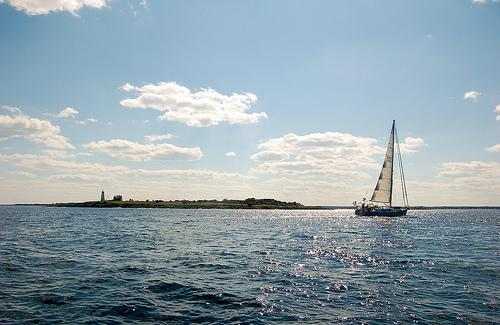Describe the quality of the light and its effect in the image. The light is bright and creates a reflection of sunlight in the calm blue water. In the context of object detection, how many separate object descriptions are provided in the image? There are 40 separate object descriptions in the image. What does the boat in the image look like and what is it doing? The boat is blue and white, sailing calmly on the water near land and a small island. Based on the visual elements, describe the general sentiment of the image. The image has a peaceful and serene sentiment, with calm water, clear sky, and gentle sailing. Analyze the interaction between the main objects in the image. The sailboat is sailing on the water near the land and small island, with the lighthouse visible in the distance. Identify the type of boat in the image and mention any visible parts of it. It's a sailboat with a white sail and a blue body, sailing on calm water. Who are the mentioned photographers or owners of this photo? Jackson Mingus and Zander Zeke are associated with this photo. Provide a brief description of the location where this photo was taken, including any landmarks. The photo was taken on the east coast in Boston, featuring a lighthouse, a small island, and an American flag. Can you count the number of objects described as "white clouds in blue sky"?  There are 9 instances of "white clouds in blue sky" descriptions. Describe the weather and environment in the image. The weather is clear with white, fluffy clouds in the blue sky, and the environment has calm, reflective blue water. Are there dark stormy clouds in the sky? All the captions about the clouds describe them as white, fluffy, and in a blue sky. This instruction is misleading by suggesting the presence of dark stormy clouds. Is the boat near land or far from it? near land Which object has a sail on top of it? a boat What does the boat look like? The boat is small, blue and white, with a sail on top Create a story based on the elements present in the image. On a clear day with the sun shining brightly, a small blue sailboat calmly sailed through deep blue waters towards a small green island with a lighthouse. White fluffy clouds dotted the expansive blue sky, adding to the serene ambience. Describe the boat and its surroundings. The boat is blue with a white sail, on calm water near a small island with a lighthouse in the distance. Which weather elements are present in the image? white clouds, sunlight reflection Pick the words related to the island in the image. small, green, lighthouse, American flag Can you see a person standing on the sailboat? The original information has several details about the sailboat, but no information about anyone being on it. This instruction is misleading by suggesting the presence of a person on the sailboat. Can you find a purple flag on the boat? There is an American flag mentioned in the photo, but there is no information about a purple flag. This instruction is misleading by suggesting there is a purple flag on the boat. Is the lighthouse far or near the boat? far, in the distance What is the boat doing on the water? sailing Pick the words related to the water in the image. calm, blue, deep, reflecting sunlight Compose a haiku inspired by the image. Sailboat on blue sea, Is the lighthouse in the photo red and white? The original information describes the lighthouse, but no information about its color is given. This instruction is misleading by suggesting it is red and white. Which colors are most prominent in the image? blue, white, green Does the sailboat have a yellow and green sail? There are several references to the sail and the sailboat, but no information about a yellow and green sail is given. This instruction is misleading by suggesting the sail is yellow and green. Is there a large brown bear visible on the island? The original information mentions the island and the land, but there is no mention of any animals, let alone a brown bear. This instruction is misleading by suggesting the presence of a bear on the island. Explain the layout of the different elements in the image. A blue boat with a white sail on calm water, a small green island with a lighthouse and an American flag, white puffy clouds in the blue sky. Is there any particular event taking place in the image? No specific event, just a sailboat on the water What object can be seen in the distance on the island? a lighthouse What does the sky look like in the image? clear, blue with white fluffy clouds Describe the island and what it has on it. The island is small and green, with a lighthouse and an American flag on it. Choose the answer that best describes the sky. b) clear, blue with white fluffy clouds 